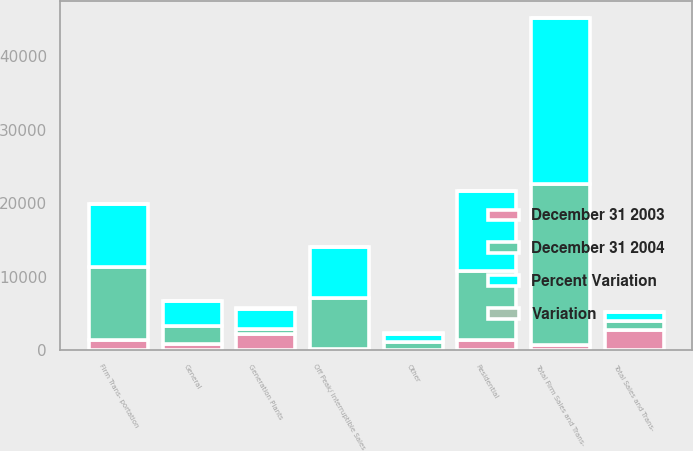<chart> <loc_0><loc_0><loc_500><loc_500><stacked_bar_chart><ecel><fcel>Residential<fcel>General<fcel>Firm Trans- portation<fcel>Total Firm Sales and Trans-<fcel>Off Peak/ Interruptible Sales<fcel>Generation Plants<fcel>Other<fcel>Total Sales and Trans-<nl><fcel>December 31 2004<fcel>9487<fcel>2487<fcel>9931<fcel>21905<fcel>6996<fcel>659<fcel>1068<fcel>1228.5<nl><fcel>Percent Variation<fcel>10810<fcel>3314<fcel>8498<fcel>22622<fcel>6833<fcel>2833<fcel>1134<fcel>1228.5<nl><fcel>December 31 2003<fcel>1323<fcel>827<fcel>1433<fcel>717<fcel>163<fcel>2174<fcel>66<fcel>2794<nl><fcel>Variation<fcel>12.2<fcel>25<fcel>16.9<fcel>3.2<fcel>2.4<fcel>76.7<fcel>5.8<fcel>8.4<nl></chart> 